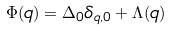Convert formula to latex. <formula><loc_0><loc_0><loc_500><loc_500>\Phi ( q ) = \Delta _ { 0 } \delta _ { q , 0 } + \Lambda ( q )</formula> 